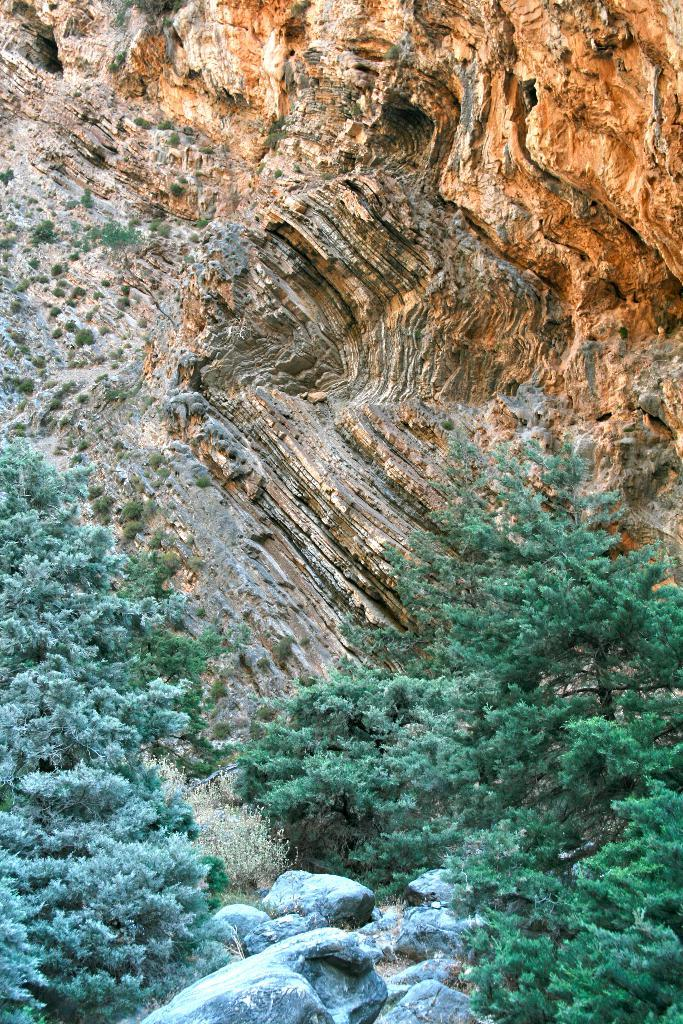What type of natural elements can be seen in the image? There are stones and trees in the image. Where are the stones and trees located in the image? The stones and trees are in the middle of the image. What is visible at the top of the image? There is a hill visible at the top of the image. What color is the toe of the person standing on the hill in the image? There is no person or toe visible in the image; it only features stones, trees, and a hill. 